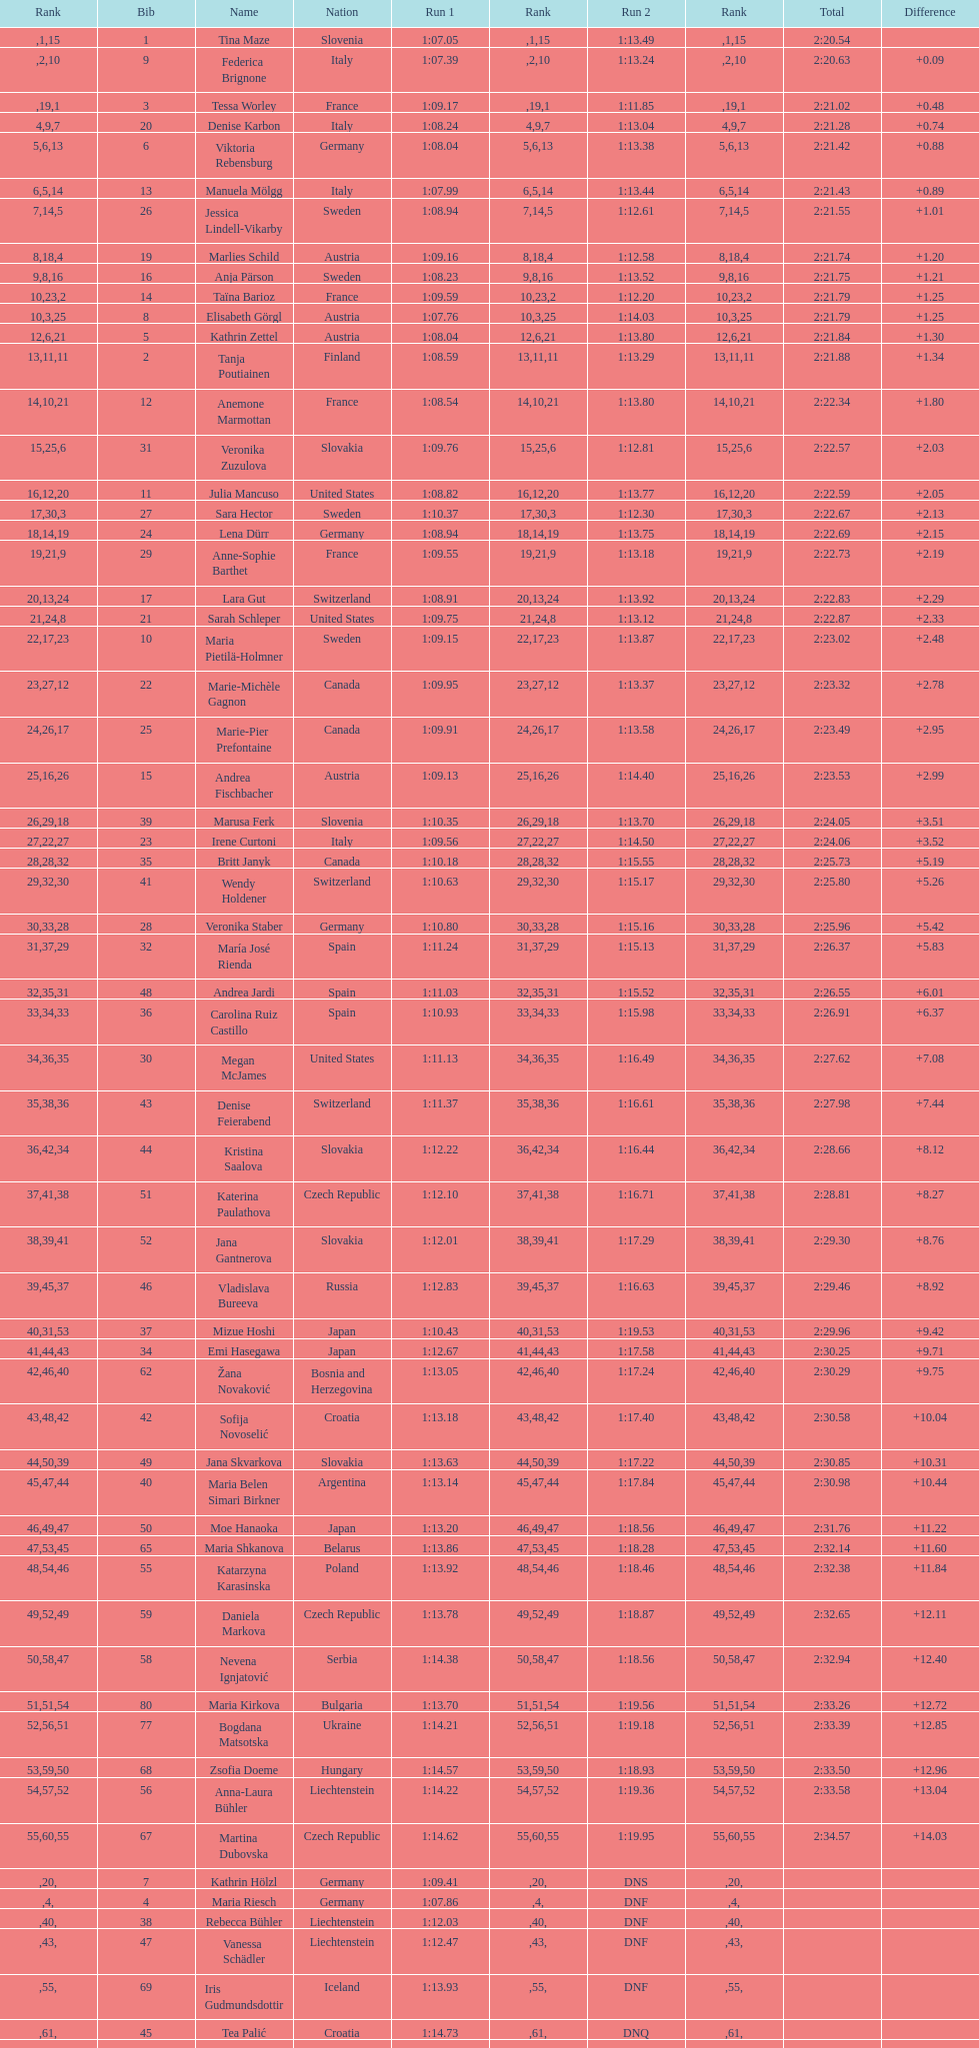Who was the person to complete after federica brignone? Tessa Worley. 